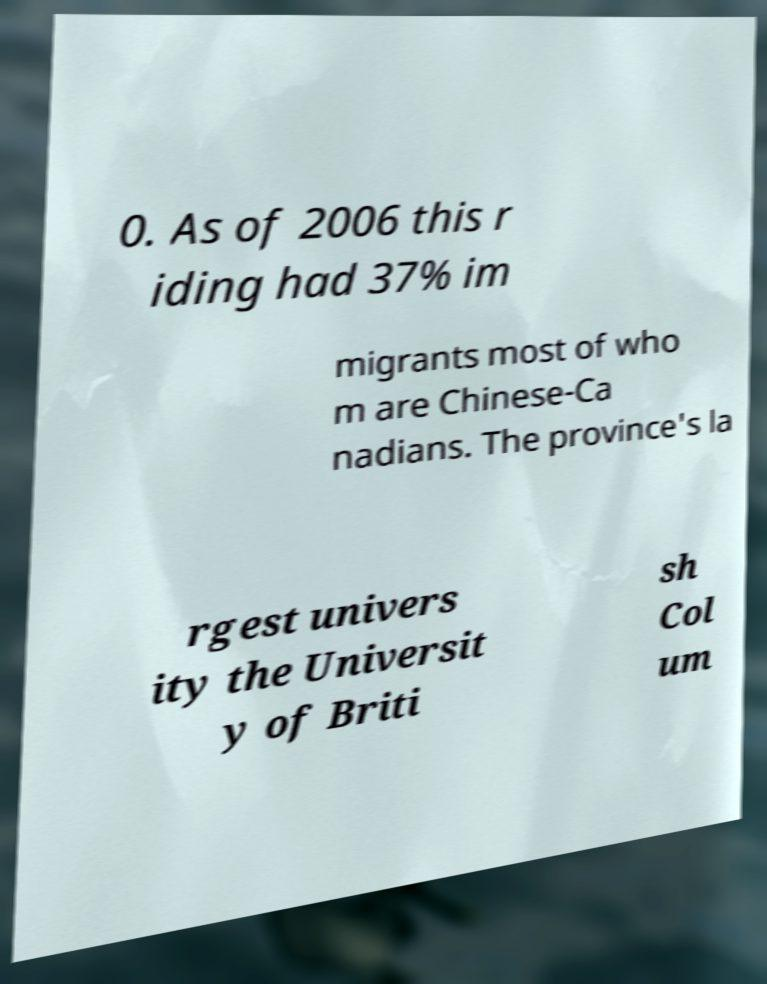What messages or text are displayed in this image? I need them in a readable, typed format. 0. As of 2006 this r iding had 37% im migrants most of who m are Chinese-Ca nadians. The province's la rgest univers ity the Universit y of Briti sh Col um 